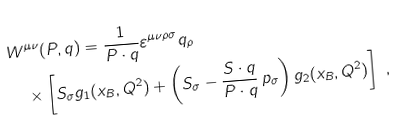Convert formula to latex. <formula><loc_0><loc_0><loc_500><loc_500>& W ^ { \mu \nu } ( P , q ) = \frac { 1 } { P \cdot q } \varepsilon ^ { \mu \nu \rho \sigma } q _ { \rho } \\ & \quad \times \left [ S _ { \sigma } g _ { 1 } ( x _ { B } , Q ^ { 2 } ) + \left ( S _ { \sigma } - \frac { S \cdot q } { P \cdot q } \, p _ { \sigma } \right ) g _ { 2 } ( x _ { B } , Q ^ { 2 } ) \right ] \ ,</formula> 